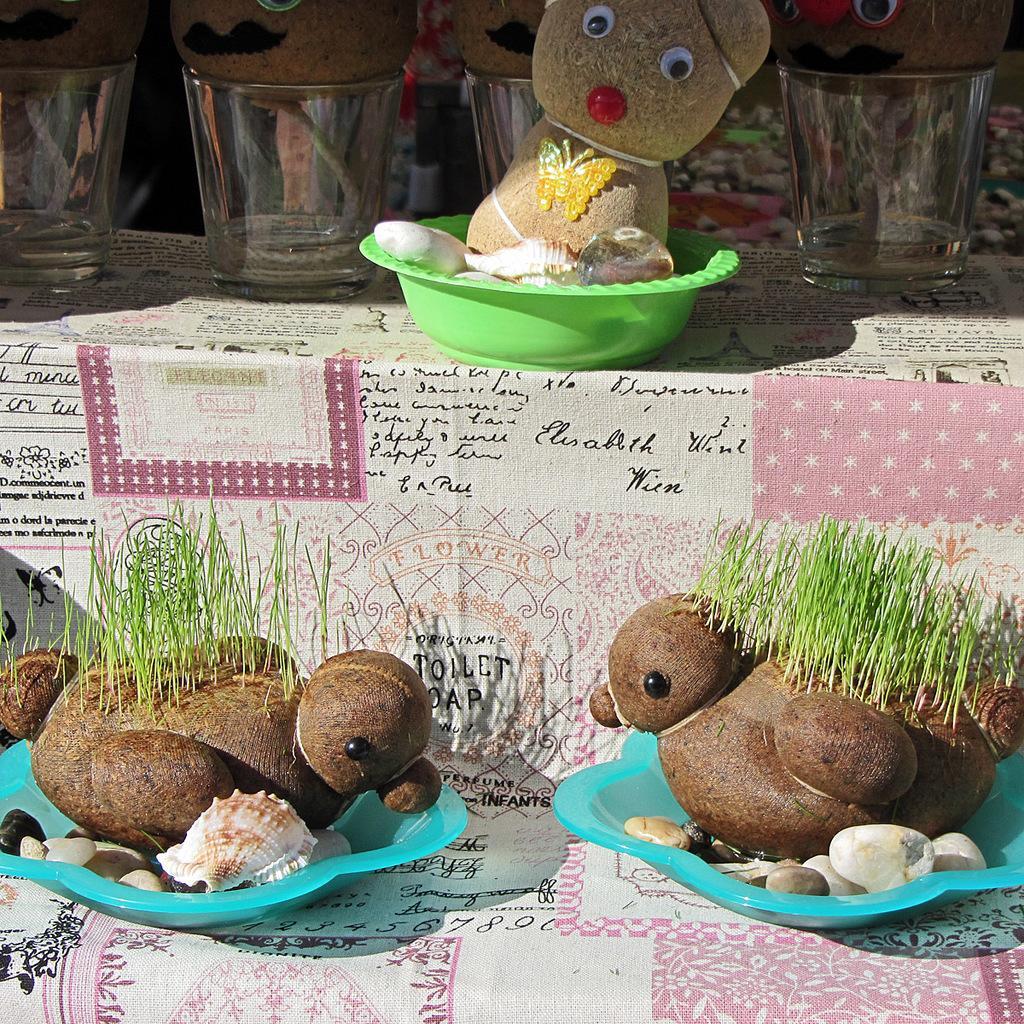Could you give a brief overview of what you see in this image? In the foreground of the picture there are plates, in the plates there are stones and duck shaped toys. At the top there are glasses, plates, tables and teddy bears. 